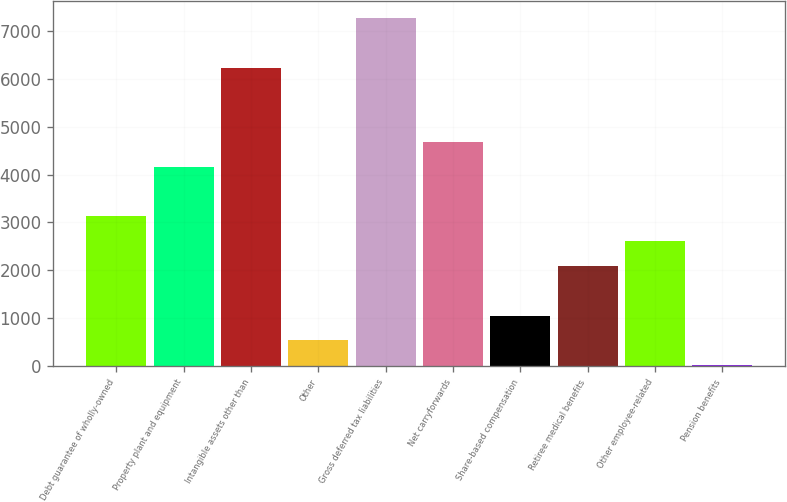Convert chart. <chart><loc_0><loc_0><loc_500><loc_500><bar_chart><fcel>Debt guarantee of wholly-owned<fcel>Property plant and equipment<fcel>Intangible assets other than<fcel>Other<fcel>Gross deferred tax liabilities<fcel>Net carryforwards<fcel>Share-based compensation<fcel>Retiree medical benefits<fcel>Other employee-related<fcel>Pension benefits<nl><fcel>3125.2<fcel>4159.6<fcel>6228.4<fcel>539.2<fcel>7262.8<fcel>4676.8<fcel>1056.4<fcel>2090.8<fcel>2608<fcel>22<nl></chart> 